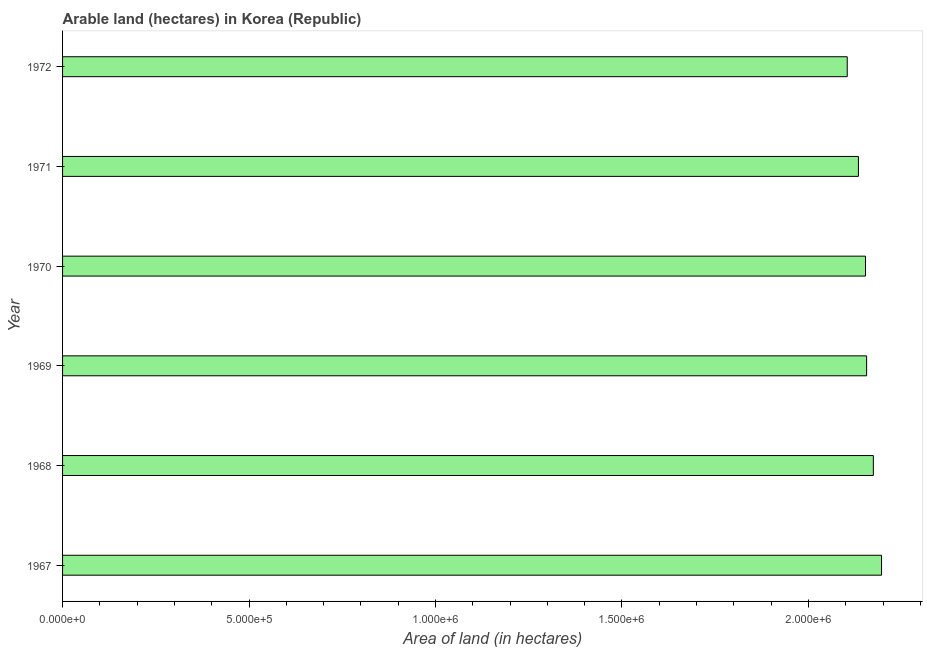What is the title of the graph?
Provide a succinct answer. Arable land (hectares) in Korea (Republic). What is the label or title of the X-axis?
Your answer should be compact. Area of land (in hectares). What is the area of land in 1972?
Your answer should be compact. 2.10e+06. Across all years, what is the maximum area of land?
Offer a very short reply. 2.20e+06. Across all years, what is the minimum area of land?
Your answer should be compact. 2.10e+06. In which year was the area of land maximum?
Offer a terse response. 1967. In which year was the area of land minimum?
Make the answer very short. 1972. What is the sum of the area of land?
Provide a short and direct response. 1.29e+07. What is the difference between the area of land in 1969 and 1971?
Keep it short and to the point. 2.20e+04. What is the average area of land per year?
Keep it short and to the point. 2.15e+06. What is the median area of land?
Ensure brevity in your answer.  2.15e+06. What is the difference between the highest and the second highest area of land?
Your answer should be compact. 2.20e+04. What is the difference between the highest and the lowest area of land?
Make the answer very short. 9.20e+04. In how many years, is the area of land greater than the average area of land taken over all years?
Offer a very short reply. 4. How many bars are there?
Your answer should be compact. 6. Are all the bars in the graph horizontal?
Keep it short and to the point. Yes. How many years are there in the graph?
Offer a very short reply. 6. What is the difference between two consecutive major ticks on the X-axis?
Offer a very short reply. 5.00e+05. Are the values on the major ticks of X-axis written in scientific E-notation?
Offer a very short reply. Yes. What is the Area of land (in hectares) in 1967?
Your answer should be very brief. 2.20e+06. What is the Area of land (in hectares) of 1968?
Your answer should be very brief. 2.17e+06. What is the Area of land (in hectares) in 1969?
Ensure brevity in your answer.  2.16e+06. What is the Area of land (in hectares) of 1970?
Ensure brevity in your answer.  2.15e+06. What is the Area of land (in hectares) in 1971?
Give a very brief answer. 2.13e+06. What is the Area of land (in hectares) of 1972?
Your answer should be very brief. 2.10e+06. What is the difference between the Area of land (in hectares) in 1967 and 1968?
Keep it short and to the point. 2.20e+04. What is the difference between the Area of land (in hectares) in 1967 and 1969?
Provide a short and direct response. 4.00e+04. What is the difference between the Area of land (in hectares) in 1967 and 1970?
Offer a very short reply. 4.30e+04. What is the difference between the Area of land (in hectares) in 1967 and 1971?
Your answer should be very brief. 6.20e+04. What is the difference between the Area of land (in hectares) in 1967 and 1972?
Keep it short and to the point. 9.20e+04. What is the difference between the Area of land (in hectares) in 1968 and 1969?
Ensure brevity in your answer.  1.80e+04. What is the difference between the Area of land (in hectares) in 1968 and 1970?
Offer a very short reply. 2.10e+04. What is the difference between the Area of land (in hectares) in 1969 and 1970?
Keep it short and to the point. 3000. What is the difference between the Area of land (in hectares) in 1969 and 1971?
Keep it short and to the point. 2.20e+04. What is the difference between the Area of land (in hectares) in 1969 and 1972?
Make the answer very short. 5.20e+04. What is the difference between the Area of land (in hectares) in 1970 and 1971?
Ensure brevity in your answer.  1.90e+04. What is the difference between the Area of land (in hectares) in 1970 and 1972?
Your answer should be very brief. 4.90e+04. What is the difference between the Area of land (in hectares) in 1971 and 1972?
Provide a short and direct response. 3.00e+04. What is the ratio of the Area of land (in hectares) in 1967 to that in 1972?
Your response must be concise. 1.04. What is the ratio of the Area of land (in hectares) in 1968 to that in 1970?
Make the answer very short. 1.01. What is the ratio of the Area of land (in hectares) in 1968 to that in 1972?
Offer a very short reply. 1.03. What is the ratio of the Area of land (in hectares) in 1969 to that in 1971?
Your answer should be very brief. 1.01. What is the ratio of the Area of land (in hectares) in 1969 to that in 1972?
Ensure brevity in your answer.  1.02. What is the ratio of the Area of land (in hectares) in 1970 to that in 1972?
Your response must be concise. 1.02. 